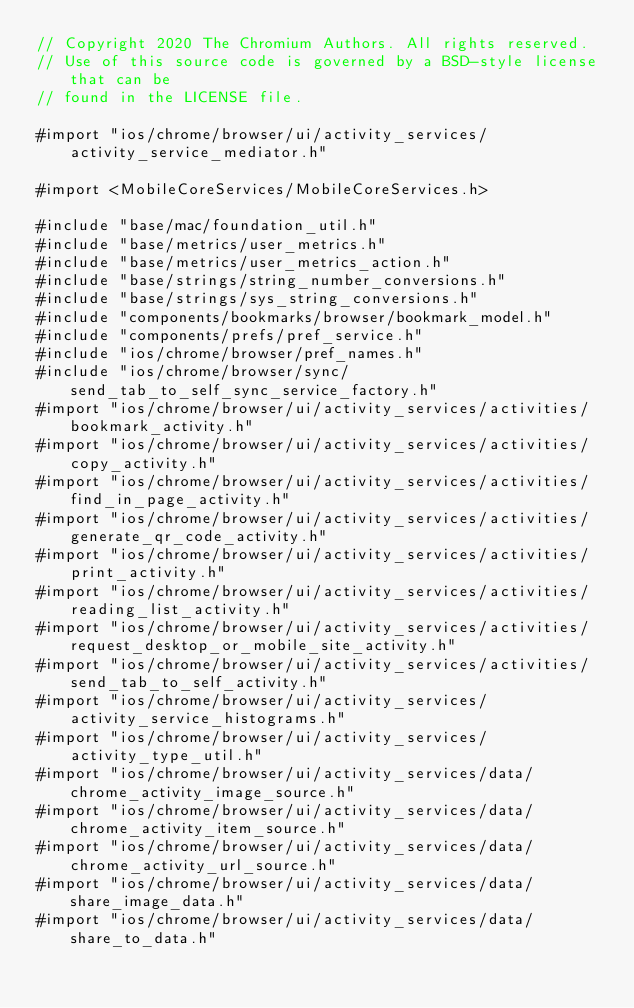Convert code to text. <code><loc_0><loc_0><loc_500><loc_500><_ObjectiveC_>// Copyright 2020 The Chromium Authors. All rights reserved.
// Use of this source code is governed by a BSD-style license that can be
// found in the LICENSE file.

#import "ios/chrome/browser/ui/activity_services/activity_service_mediator.h"

#import <MobileCoreServices/MobileCoreServices.h>

#include "base/mac/foundation_util.h"
#include "base/metrics/user_metrics.h"
#include "base/metrics/user_metrics_action.h"
#include "base/strings/string_number_conversions.h"
#include "base/strings/sys_string_conversions.h"
#include "components/bookmarks/browser/bookmark_model.h"
#include "components/prefs/pref_service.h"
#include "ios/chrome/browser/pref_names.h"
#include "ios/chrome/browser/sync/send_tab_to_self_sync_service_factory.h"
#import "ios/chrome/browser/ui/activity_services/activities/bookmark_activity.h"
#import "ios/chrome/browser/ui/activity_services/activities/copy_activity.h"
#import "ios/chrome/browser/ui/activity_services/activities/find_in_page_activity.h"
#import "ios/chrome/browser/ui/activity_services/activities/generate_qr_code_activity.h"
#import "ios/chrome/browser/ui/activity_services/activities/print_activity.h"
#import "ios/chrome/browser/ui/activity_services/activities/reading_list_activity.h"
#import "ios/chrome/browser/ui/activity_services/activities/request_desktop_or_mobile_site_activity.h"
#import "ios/chrome/browser/ui/activity_services/activities/send_tab_to_self_activity.h"
#import "ios/chrome/browser/ui/activity_services/activity_service_histograms.h"
#import "ios/chrome/browser/ui/activity_services/activity_type_util.h"
#import "ios/chrome/browser/ui/activity_services/data/chrome_activity_image_source.h"
#import "ios/chrome/browser/ui/activity_services/data/chrome_activity_item_source.h"
#import "ios/chrome/browser/ui/activity_services/data/chrome_activity_url_source.h"
#import "ios/chrome/browser/ui/activity_services/data/share_image_data.h"
#import "ios/chrome/browser/ui/activity_services/data/share_to_data.h"</code> 